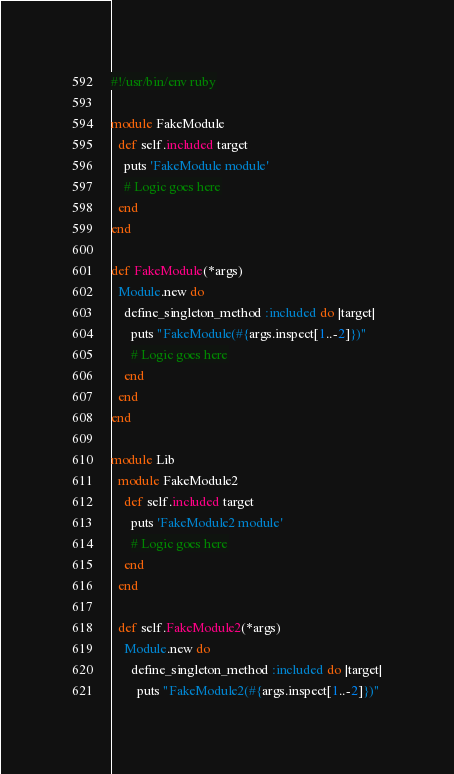Convert code to text. <code><loc_0><loc_0><loc_500><loc_500><_Ruby_>#!/usr/bin/env ruby

module FakeModule
  def self.included target
    puts 'FakeModule module'
    # Logic goes here
  end
end

def FakeModule(*args)
  Module.new do
    define_singleton_method :included do |target|
      puts "FakeModule(#{args.inspect[1..-2]})"
      # Logic goes here
    end
  end
end

module Lib
  module FakeModule2
    def self.included target
      puts 'FakeModule2 module'
      # Logic goes here
    end
  end

  def self.FakeModule2(*args)
    Module.new do
      define_singleton_method :included do |target|
        puts "FakeModule2(#{args.inspect[1..-2]})"</code> 